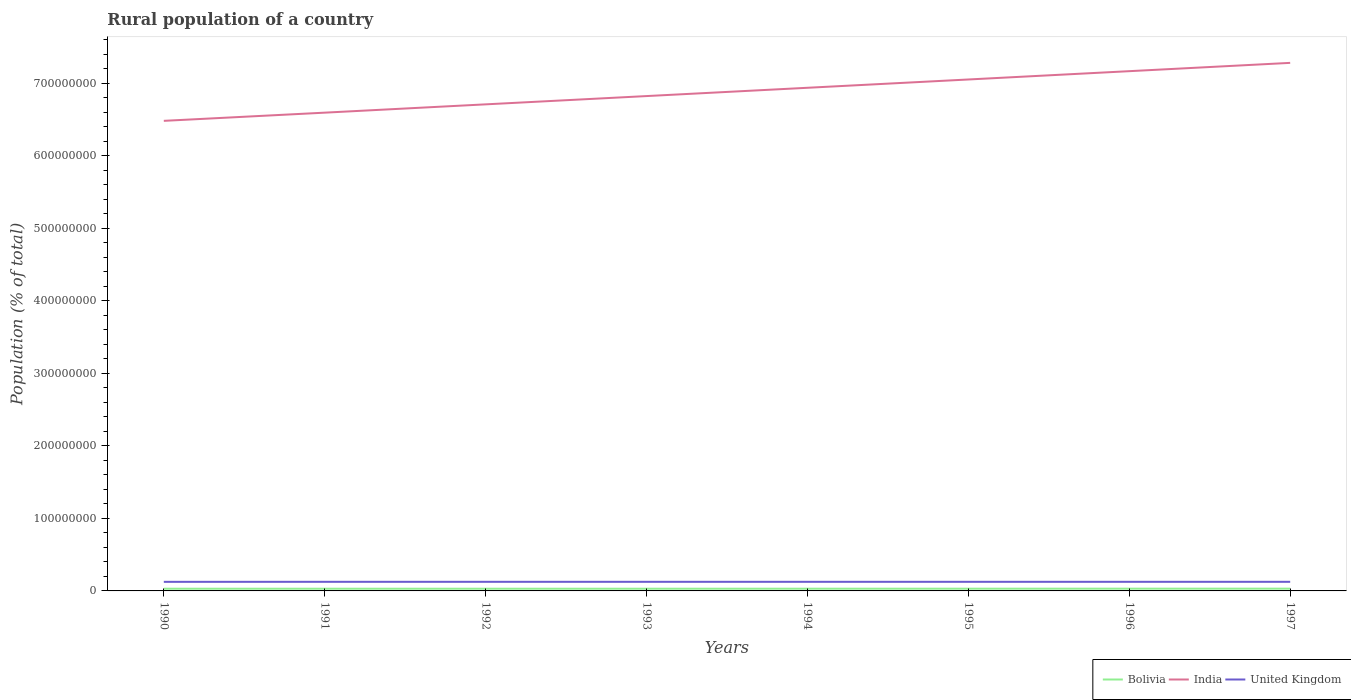Does the line corresponding to India intersect with the line corresponding to United Kingdom?
Keep it short and to the point. No. Across all years, what is the maximum rural population in Bolivia?
Your answer should be very brief. 3.03e+06. In which year was the rural population in Bolivia maximum?
Keep it short and to the point. 1992. What is the total rural population in Bolivia in the graph?
Offer a very short reply. -5.92e+04. What is the difference between the highest and the second highest rural population in Bolivia?
Ensure brevity in your answer.  9.09e+04. Is the rural population in Bolivia strictly greater than the rural population in India over the years?
Your answer should be very brief. Yes. How many years are there in the graph?
Keep it short and to the point. 8. What is the difference between two consecutive major ticks on the Y-axis?
Offer a very short reply. 1.00e+08. Are the values on the major ticks of Y-axis written in scientific E-notation?
Offer a terse response. No. What is the title of the graph?
Make the answer very short. Rural population of a country. What is the label or title of the Y-axis?
Ensure brevity in your answer.  Population (% of total). What is the Population (% of total) in Bolivia in 1990?
Provide a short and direct response. 3.05e+06. What is the Population (% of total) of India in 1990?
Your answer should be compact. 6.48e+08. What is the Population (% of total) in United Kingdom in 1990?
Your response must be concise. 1.25e+07. What is the Population (% of total) of Bolivia in 1991?
Ensure brevity in your answer.  3.04e+06. What is the Population (% of total) of India in 1991?
Give a very brief answer. 6.59e+08. What is the Population (% of total) of United Kingdom in 1991?
Provide a short and direct response. 1.26e+07. What is the Population (% of total) of Bolivia in 1992?
Provide a short and direct response. 3.03e+06. What is the Population (% of total) of India in 1992?
Your answer should be very brief. 6.71e+08. What is the Population (% of total) of United Kingdom in 1992?
Your answer should be compact. 1.26e+07. What is the Population (% of total) in Bolivia in 1993?
Offer a very short reply. 3.04e+06. What is the Population (% of total) in India in 1993?
Your answer should be very brief. 6.82e+08. What is the Population (% of total) of United Kingdom in 1993?
Ensure brevity in your answer.  1.26e+07. What is the Population (% of total) in Bolivia in 1994?
Give a very brief answer. 3.06e+06. What is the Population (% of total) of India in 1994?
Offer a very short reply. 6.94e+08. What is the Population (% of total) in United Kingdom in 1994?
Provide a short and direct response. 1.26e+07. What is the Population (% of total) of Bolivia in 1995?
Provide a succinct answer. 3.07e+06. What is the Population (% of total) in India in 1995?
Your answer should be very brief. 7.05e+08. What is the Population (% of total) of United Kingdom in 1995?
Give a very brief answer. 1.26e+07. What is the Population (% of total) in Bolivia in 1996?
Offer a terse response. 3.10e+06. What is the Population (% of total) in India in 1996?
Give a very brief answer. 7.17e+08. What is the Population (% of total) in United Kingdom in 1996?
Offer a terse response. 1.26e+07. What is the Population (% of total) in Bolivia in 1997?
Ensure brevity in your answer.  3.12e+06. What is the Population (% of total) in India in 1997?
Your answer should be compact. 7.28e+08. What is the Population (% of total) in United Kingdom in 1997?
Ensure brevity in your answer.  1.26e+07. Across all years, what is the maximum Population (% of total) in Bolivia?
Provide a succinct answer. 3.12e+06. Across all years, what is the maximum Population (% of total) of India?
Provide a succinct answer. 7.28e+08. Across all years, what is the maximum Population (% of total) of United Kingdom?
Your response must be concise. 1.26e+07. Across all years, what is the minimum Population (% of total) in Bolivia?
Ensure brevity in your answer.  3.03e+06. Across all years, what is the minimum Population (% of total) in India?
Provide a short and direct response. 6.48e+08. Across all years, what is the minimum Population (% of total) in United Kingdom?
Your answer should be very brief. 1.25e+07. What is the total Population (% of total) of Bolivia in the graph?
Keep it short and to the point. 2.45e+07. What is the total Population (% of total) of India in the graph?
Make the answer very short. 5.50e+09. What is the total Population (% of total) of United Kingdom in the graph?
Offer a terse response. 1.00e+08. What is the difference between the Population (% of total) of Bolivia in 1990 and that in 1991?
Provide a succinct answer. 9527. What is the difference between the Population (% of total) of India in 1990 and that in 1991?
Offer a very short reply. -1.13e+07. What is the difference between the Population (% of total) of United Kingdom in 1990 and that in 1991?
Provide a succinct answer. -5.48e+04. What is the difference between the Population (% of total) of Bolivia in 1990 and that in 1992?
Give a very brief answer. 1.82e+04. What is the difference between the Population (% of total) in India in 1990 and that in 1992?
Your answer should be very brief. -2.27e+07. What is the difference between the Population (% of total) of United Kingdom in 1990 and that in 1992?
Your answer should be compact. -5.43e+04. What is the difference between the Population (% of total) in Bolivia in 1990 and that in 1993?
Ensure brevity in your answer.  2891. What is the difference between the Population (% of total) in India in 1990 and that in 1993?
Make the answer very short. -3.42e+07. What is the difference between the Population (% of total) of United Kingdom in 1990 and that in 1993?
Your answer should be very brief. -4.99e+04. What is the difference between the Population (% of total) of Bolivia in 1990 and that in 1994?
Give a very brief answer. -1.19e+04. What is the difference between the Population (% of total) in India in 1990 and that in 1994?
Offer a very short reply. -4.56e+07. What is the difference between the Population (% of total) in United Kingdom in 1990 and that in 1994?
Make the answer very short. -4.66e+04. What is the difference between the Population (% of total) in Bolivia in 1990 and that in 1995?
Your answer should be compact. -2.63e+04. What is the difference between the Population (% of total) of India in 1990 and that in 1995?
Provide a short and direct response. -5.70e+07. What is the difference between the Population (% of total) in United Kingdom in 1990 and that in 1995?
Your response must be concise. -4.51e+04. What is the difference between the Population (% of total) of Bolivia in 1990 and that in 1996?
Your response must be concise. -4.96e+04. What is the difference between the Population (% of total) of India in 1990 and that in 1996?
Your response must be concise. -6.85e+07. What is the difference between the Population (% of total) of United Kingdom in 1990 and that in 1996?
Provide a succinct answer. -4.22e+04. What is the difference between the Population (% of total) of Bolivia in 1990 and that in 1997?
Offer a very short reply. -7.27e+04. What is the difference between the Population (% of total) of India in 1990 and that in 1997?
Your response must be concise. -7.99e+07. What is the difference between the Population (% of total) in United Kingdom in 1990 and that in 1997?
Provide a succinct answer. -4.02e+04. What is the difference between the Population (% of total) in Bolivia in 1991 and that in 1992?
Your response must be concise. 8674. What is the difference between the Population (% of total) in India in 1991 and that in 1992?
Keep it short and to the point. -1.15e+07. What is the difference between the Population (% of total) of United Kingdom in 1991 and that in 1992?
Provide a succinct answer. 511. What is the difference between the Population (% of total) of Bolivia in 1991 and that in 1993?
Your answer should be very brief. -6636. What is the difference between the Population (% of total) in India in 1991 and that in 1993?
Offer a very short reply. -2.29e+07. What is the difference between the Population (% of total) of United Kingdom in 1991 and that in 1993?
Give a very brief answer. 4973. What is the difference between the Population (% of total) of Bolivia in 1991 and that in 1994?
Offer a very short reply. -2.15e+04. What is the difference between the Population (% of total) of India in 1991 and that in 1994?
Your response must be concise. -3.43e+07. What is the difference between the Population (% of total) of United Kingdom in 1991 and that in 1994?
Give a very brief answer. 8244. What is the difference between the Population (% of total) of Bolivia in 1991 and that in 1995?
Keep it short and to the point. -3.59e+04. What is the difference between the Population (% of total) in India in 1991 and that in 1995?
Your response must be concise. -4.57e+07. What is the difference between the Population (% of total) in United Kingdom in 1991 and that in 1995?
Give a very brief answer. 9782. What is the difference between the Population (% of total) of Bolivia in 1991 and that in 1996?
Offer a terse response. -5.92e+04. What is the difference between the Population (% of total) of India in 1991 and that in 1996?
Provide a succinct answer. -5.72e+07. What is the difference between the Population (% of total) in United Kingdom in 1991 and that in 1996?
Your answer should be compact. 1.27e+04. What is the difference between the Population (% of total) of Bolivia in 1991 and that in 1997?
Offer a terse response. -8.22e+04. What is the difference between the Population (% of total) in India in 1991 and that in 1997?
Offer a very short reply. -6.87e+07. What is the difference between the Population (% of total) in United Kingdom in 1991 and that in 1997?
Offer a terse response. 1.47e+04. What is the difference between the Population (% of total) of Bolivia in 1992 and that in 1993?
Provide a short and direct response. -1.53e+04. What is the difference between the Population (% of total) in India in 1992 and that in 1993?
Your response must be concise. -1.14e+07. What is the difference between the Population (% of total) of United Kingdom in 1992 and that in 1993?
Provide a succinct answer. 4462. What is the difference between the Population (% of total) of Bolivia in 1992 and that in 1994?
Provide a succinct answer. -3.01e+04. What is the difference between the Population (% of total) in India in 1992 and that in 1994?
Keep it short and to the point. -2.28e+07. What is the difference between the Population (% of total) in United Kingdom in 1992 and that in 1994?
Offer a very short reply. 7733. What is the difference between the Population (% of total) of Bolivia in 1992 and that in 1995?
Your answer should be compact. -4.45e+04. What is the difference between the Population (% of total) in India in 1992 and that in 1995?
Your answer should be very brief. -3.43e+07. What is the difference between the Population (% of total) in United Kingdom in 1992 and that in 1995?
Ensure brevity in your answer.  9271. What is the difference between the Population (% of total) of Bolivia in 1992 and that in 1996?
Your answer should be very brief. -6.78e+04. What is the difference between the Population (% of total) in India in 1992 and that in 1996?
Provide a short and direct response. -4.57e+07. What is the difference between the Population (% of total) in United Kingdom in 1992 and that in 1996?
Offer a terse response. 1.22e+04. What is the difference between the Population (% of total) in Bolivia in 1992 and that in 1997?
Provide a short and direct response. -9.09e+04. What is the difference between the Population (% of total) of India in 1992 and that in 1997?
Make the answer very short. -5.72e+07. What is the difference between the Population (% of total) in United Kingdom in 1992 and that in 1997?
Ensure brevity in your answer.  1.42e+04. What is the difference between the Population (% of total) of Bolivia in 1993 and that in 1994?
Your answer should be compact. -1.48e+04. What is the difference between the Population (% of total) in India in 1993 and that in 1994?
Your answer should be very brief. -1.14e+07. What is the difference between the Population (% of total) in United Kingdom in 1993 and that in 1994?
Provide a succinct answer. 3271. What is the difference between the Population (% of total) in Bolivia in 1993 and that in 1995?
Offer a very short reply. -2.92e+04. What is the difference between the Population (% of total) of India in 1993 and that in 1995?
Your response must be concise. -2.29e+07. What is the difference between the Population (% of total) of United Kingdom in 1993 and that in 1995?
Give a very brief answer. 4809. What is the difference between the Population (% of total) of Bolivia in 1993 and that in 1996?
Your answer should be very brief. -5.25e+04. What is the difference between the Population (% of total) in India in 1993 and that in 1996?
Make the answer very short. -3.43e+07. What is the difference between the Population (% of total) of United Kingdom in 1993 and that in 1996?
Give a very brief answer. 7689. What is the difference between the Population (% of total) of Bolivia in 1993 and that in 1997?
Provide a succinct answer. -7.56e+04. What is the difference between the Population (% of total) of India in 1993 and that in 1997?
Make the answer very short. -4.58e+07. What is the difference between the Population (% of total) of United Kingdom in 1993 and that in 1997?
Your answer should be very brief. 9714. What is the difference between the Population (% of total) in Bolivia in 1994 and that in 1995?
Make the answer very short. -1.44e+04. What is the difference between the Population (% of total) of India in 1994 and that in 1995?
Your answer should be very brief. -1.14e+07. What is the difference between the Population (% of total) of United Kingdom in 1994 and that in 1995?
Make the answer very short. 1538. What is the difference between the Population (% of total) of Bolivia in 1994 and that in 1996?
Your answer should be compact. -3.77e+04. What is the difference between the Population (% of total) of India in 1994 and that in 1996?
Ensure brevity in your answer.  -2.29e+07. What is the difference between the Population (% of total) in United Kingdom in 1994 and that in 1996?
Ensure brevity in your answer.  4418. What is the difference between the Population (% of total) in Bolivia in 1994 and that in 1997?
Give a very brief answer. -6.08e+04. What is the difference between the Population (% of total) in India in 1994 and that in 1997?
Your answer should be compact. -3.44e+07. What is the difference between the Population (% of total) of United Kingdom in 1994 and that in 1997?
Your answer should be compact. 6443. What is the difference between the Population (% of total) in Bolivia in 1995 and that in 1996?
Your answer should be very brief. -2.33e+04. What is the difference between the Population (% of total) in India in 1995 and that in 1996?
Provide a succinct answer. -1.15e+07. What is the difference between the Population (% of total) in United Kingdom in 1995 and that in 1996?
Keep it short and to the point. 2880. What is the difference between the Population (% of total) in Bolivia in 1995 and that in 1997?
Your answer should be very brief. -4.63e+04. What is the difference between the Population (% of total) in India in 1995 and that in 1997?
Ensure brevity in your answer.  -2.29e+07. What is the difference between the Population (% of total) of United Kingdom in 1995 and that in 1997?
Your answer should be very brief. 4905. What is the difference between the Population (% of total) in Bolivia in 1996 and that in 1997?
Your answer should be compact. -2.30e+04. What is the difference between the Population (% of total) in India in 1996 and that in 1997?
Provide a short and direct response. -1.15e+07. What is the difference between the Population (% of total) in United Kingdom in 1996 and that in 1997?
Offer a very short reply. 2025. What is the difference between the Population (% of total) in Bolivia in 1990 and the Population (% of total) in India in 1991?
Your response must be concise. -6.56e+08. What is the difference between the Population (% of total) of Bolivia in 1990 and the Population (% of total) of United Kingdom in 1991?
Provide a succinct answer. -9.52e+06. What is the difference between the Population (% of total) in India in 1990 and the Population (% of total) in United Kingdom in 1991?
Offer a very short reply. 6.36e+08. What is the difference between the Population (% of total) of Bolivia in 1990 and the Population (% of total) of India in 1992?
Your response must be concise. -6.68e+08. What is the difference between the Population (% of total) of Bolivia in 1990 and the Population (% of total) of United Kingdom in 1992?
Your answer should be compact. -9.52e+06. What is the difference between the Population (% of total) of India in 1990 and the Population (% of total) of United Kingdom in 1992?
Offer a terse response. 6.36e+08. What is the difference between the Population (% of total) in Bolivia in 1990 and the Population (% of total) in India in 1993?
Keep it short and to the point. -6.79e+08. What is the difference between the Population (% of total) in Bolivia in 1990 and the Population (% of total) in United Kingdom in 1993?
Your answer should be compact. -9.52e+06. What is the difference between the Population (% of total) of India in 1990 and the Population (% of total) of United Kingdom in 1993?
Keep it short and to the point. 6.36e+08. What is the difference between the Population (% of total) in Bolivia in 1990 and the Population (% of total) in India in 1994?
Offer a terse response. -6.91e+08. What is the difference between the Population (% of total) in Bolivia in 1990 and the Population (% of total) in United Kingdom in 1994?
Your answer should be very brief. -9.52e+06. What is the difference between the Population (% of total) of India in 1990 and the Population (% of total) of United Kingdom in 1994?
Provide a short and direct response. 6.36e+08. What is the difference between the Population (% of total) in Bolivia in 1990 and the Population (% of total) in India in 1995?
Your answer should be very brief. -7.02e+08. What is the difference between the Population (% of total) of Bolivia in 1990 and the Population (% of total) of United Kingdom in 1995?
Make the answer very short. -9.51e+06. What is the difference between the Population (% of total) of India in 1990 and the Population (% of total) of United Kingdom in 1995?
Make the answer very short. 6.36e+08. What is the difference between the Population (% of total) in Bolivia in 1990 and the Population (% of total) in India in 1996?
Offer a very short reply. -7.14e+08. What is the difference between the Population (% of total) in Bolivia in 1990 and the Population (% of total) in United Kingdom in 1996?
Provide a short and direct response. -9.51e+06. What is the difference between the Population (% of total) of India in 1990 and the Population (% of total) of United Kingdom in 1996?
Give a very brief answer. 6.36e+08. What is the difference between the Population (% of total) in Bolivia in 1990 and the Population (% of total) in India in 1997?
Give a very brief answer. -7.25e+08. What is the difference between the Population (% of total) in Bolivia in 1990 and the Population (% of total) in United Kingdom in 1997?
Provide a short and direct response. -9.51e+06. What is the difference between the Population (% of total) in India in 1990 and the Population (% of total) in United Kingdom in 1997?
Keep it short and to the point. 6.36e+08. What is the difference between the Population (% of total) of Bolivia in 1991 and the Population (% of total) of India in 1992?
Your answer should be compact. -6.68e+08. What is the difference between the Population (% of total) in Bolivia in 1991 and the Population (% of total) in United Kingdom in 1992?
Your response must be concise. -9.53e+06. What is the difference between the Population (% of total) of India in 1991 and the Population (% of total) of United Kingdom in 1992?
Make the answer very short. 6.47e+08. What is the difference between the Population (% of total) of Bolivia in 1991 and the Population (% of total) of India in 1993?
Your response must be concise. -6.79e+08. What is the difference between the Population (% of total) in Bolivia in 1991 and the Population (% of total) in United Kingdom in 1993?
Offer a very short reply. -9.53e+06. What is the difference between the Population (% of total) in India in 1991 and the Population (% of total) in United Kingdom in 1993?
Keep it short and to the point. 6.47e+08. What is the difference between the Population (% of total) of Bolivia in 1991 and the Population (% of total) of India in 1994?
Offer a very short reply. -6.91e+08. What is the difference between the Population (% of total) of Bolivia in 1991 and the Population (% of total) of United Kingdom in 1994?
Your answer should be compact. -9.52e+06. What is the difference between the Population (% of total) in India in 1991 and the Population (% of total) in United Kingdom in 1994?
Make the answer very short. 6.47e+08. What is the difference between the Population (% of total) in Bolivia in 1991 and the Population (% of total) in India in 1995?
Your answer should be compact. -7.02e+08. What is the difference between the Population (% of total) in Bolivia in 1991 and the Population (% of total) in United Kingdom in 1995?
Ensure brevity in your answer.  -9.52e+06. What is the difference between the Population (% of total) in India in 1991 and the Population (% of total) in United Kingdom in 1995?
Ensure brevity in your answer.  6.47e+08. What is the difference between the Population (% of total) in Bolivia in 1991 and the Population (% of total) in India in 1996?
Ensure brevity in your answer.  -7.14e+08. What is the difference between the Population (% of total) of Bolivia in 1991 and the Population (% of total) of United Kingdom in 1996?
Make the answer very short. -9.52e+06. What is the difference between the Population (% of total) in India in 1991 and the Population (% of total) in United Kingdom in 1996?
Give a very brief answer. 6.47e+08. What is the difference between the Population (% of total) in Bolivia in 1991 and the Population (% of total) in India in 1997?
Your response must be concise. -7.25e+08. What is the difference between the Population (% of total) in Bolivia in 1991 and the Population (% of total) in United Kingdom in 1997?
Your answer should be compact. -9.52e+06. What is the difference between the Population (% of total) of India in 1991 and the Population (% of total) of United Kingdom in 1997?
Make the answer very short. 6.47e+08. What is the difference between the Population (% of total) in Bolivia in 1992 and the Population (% of total) in India in 1993?
Provide a short and direct response. -6.79e+08. What is the difference between the Population (% of total) in Bolivia in 1992 and the Population (% of total) in United Kingdom in 1993?
Offer a terse response. -9.54e+06. What is the difference between the Population (% of total) in India in 1992 and the Population (% of total) in United Kingdom in 1993?
Offer a terse response. 6.58e+08. What is the difference between the Population (% of total) in Bolivia in 1992 and the Population (% of total) in India in 1994?
Offer a terse response. -6.91e+08. What is the difference between the Population (% of total) in Bolivia in 1992 and the Population (% of total) in United Kingdom in 1994?
Your response must be concise. -9.53e+06. What is the difference between the Population (% of total) of India in 1992 and the Population (% of total) of United Kingdom in 1994?
Provide a succinct answer. 6.58e+08. What is the difference between the Population (% of total) in Bolivia in 1992 and the Population (% of total) in India in 1995?
Offer a terse response. -7.02e+08. What is the difference between the Population (% of total) of Bolivia in 1992 and the Population (% of total) of United Kingdom in 1995?
Make the answer very short. -9.53e+06. What is the difference between the Population (% of total) in India in 1992 and the Population (% of total) in United Kingdom in 1995?
Keep it short and to the point. 6.58e+08. What is the difference between the Population (% of total) of Bolivia in 1992 and the Population (% of total) of India in 1996?
Give a very brief answer. -7.14e+08. What is the difference between the Population (% of total) in Bolivia in 1992 and the Population (% of total) in United Kingdom in 1996?
Offer a terse response. -9.53e+06. What is the difference between the Population (% of total) in India in 1992 and the Population (% of total) in United Kingdom in 1996?
Offer a very short reply. 6.58e+08. What is the difference between the Population (% of total) of Bolivia in 1992 and the Population (% of total) of India in 1997?
Your answer should be very brief. -7.25e+08. What is the difference between the Population (% of total) of Bolivia in 1992 and the Population (% of total) of United Kingdom in 1997?
Offer a very short reply. -9.53e+06. What is the difference between the Population (% of total) in India in 1992 and the Population (% of total) in United Kingdom in 1997?
Provide a short and direct response. 6.58e+08. What is the difference between the Population (% of total) of Bolivia in 1993 and the Population (% of total) of India in 1994?
Make the answer very short. -6.91e+08. What is the difference between the Population (% of total) in Bolivia in 1993 and the Population (% of total) in United Kingdom in 1994?
Your response must be concise. -9.52e+06. What is the difference between the Population (% of total) in India in 1993 and the Population (% of total) in United Kingdom in 1994?
Provide a short and direct response. 6.70e+08. What is the difference between the Population (% of total) of Bolivia in 1993 and the Population (% of total) of India in 1995?
Provide a short and direct response. -7.02e+08. What is the difference between the Population (% of total) in Bolivia in 1993 and the Population (% of total) in United Kingdom in 1995?
Offer a terse response. -9.52e+06. What is the difference between the Population (% of total) in India in 1993 and the Population (% of total) in United Kingdom in 1995?
Offer a very short reply. 6.70e+08. What is the difference between the Population (% of total) of Bolivia in 1993 and the Population (% of total) of India in 1996?
Provide a succinct answer. -7.14e+08. What is the difference between the Population (% of total) in Bolivia in 1993 and the Population (% of total) in United Kingdom in 1996?
Your response must be concise. -9.51e+06. What is the difference between the Population (% of total) of India in 1993 and the Population (% of total) of United Kingdom in 1996?
Your answer should be very brief. 6.70e+08. What is the difference between the Population (% of total) in Bolivia in 1993 and the Population (% of total) in India in 1997?
Offer a terse response. -7.25e+08. What is the difference between the Population (% of total) of Bolivia in 1993 and the Population (% of total) of United Kingdom in 1997?
Offer a terse response. -9.51e+06. What is the difference between the Population (% of total) of India in 1993 and the Population (% of total) of United Kingdom in 1997?
Provide a short and direct response. 6.70e+08. What is the difference between the Population (% of total) in Bolivia in 1994 and the Population (% of total) in India in 1995?
Keep it short and to the point. -7.02e+08. What is the difference between the Population (% of total) of Bolivia in 1994 and the Population (% of total) of United Kingdom in 1995?
Your answer should be very brief. -9.50e+06. What is the difference between the Population (% of total) of India in 1994 and the Population (% of total) of United Kingdom in 1995?
Your answer should be compact. 6.81e+08. What is the difference between the Population (% of total) of Bolivia in 1994 and the Population (% of total) of India in 1996?
Ensure brevity in your answer.  -7.14e+08. What is the difference between the Population (% of total) in Bolivia in 1994 and the Population (% of total) in United Kingdom in 1996?
Offer a very short reply. -9.50e+06. What is the difference between the Population (% of total) in India in 1994 and the Population (% of total) in United Kingdom in 1996?
Make the answer very short. 6.81e+08. What is the difference between the Population (% of total) in Bolivia in 1994 and the Population (% of total) in India in 1997?
Ensure brevity in your answer.  -7.25e+08. What is the difference between the Population (% of total) in Bolivia in 1994 and the Population (% of total) in United Kingdom in 1997?
Make the answer very short. -9.50e+06. What is the difference between the Population (% of total) in India in 1994 and the Population (% of total) in United Kingdom in 1997?
Make the answer very short. 6.81e+08. What is the difference between the Population (% of total) in Bolivia in 1995 and the Population (% of total) in India in 1996?
Make the answer very short. -7.14e+08. What is the difference between the Population (% of total) of Bolivia in 1995 and the Population (% of total) of United Kingdom in 1996?
Provide a succinct answer. -9.48e+06. What is the difference between the Population (% of total) of India in 1995 and the Population (% of total) of United Kingdom in 1996?
Give a very brief answer. 6.93e+08. What is the difference between the Population (% of total) in Bolivia in 1995 and the Population (% of total) in India in 1997?
Your answer should be very brief. -7.25e+08. What is the difference between the Population (% of total) of Bolivia in 1995 and the Population (% of total) of United Kingdom in 1997?
Provide a succinct answer. -9.48e+06. What is the difference between the Population (% of total) in India in 1995 and the Population (% of total) in United Kingdom in 1997?
Your response must be concise. 6.93e+08. What is the difference between the Population (% of total) in Bolivia in 1996 and the Population (% of total) in India in 1997?
Your answer should be compact. -7.25e+08. What is the difference between the Population (% of total) in Bolivia in 1996 and the Population (% of total) in United Kingdom in 1997?
Your answer should be very brief. -9.46e+06. What is the difference between the Population (% of total) of India in 1996 and the Population (% of total) of United Kingdom in 1997?
Your answer should be compact. 7.04e+08. What is the average Population (% of total) in Bolivia per year?
Your answer should be compact. 3.06e+06. What is the average Population (% of total) of India per year?
Provide a succinct answer. 6.88e+08. What is the average Population (% of total) in United Kingdom per year?
Ensure brevity in your answer.  1.26e+07. In the year 1990, what is the difference between the Population (% of total) of Bolivia and Population (% of total) of India?
Your answer should be compact. -6.45e+08. In the year 1990, what is the difference between the Population (% of total) of Bolivia and Population (% of total) of United Kingdom?
Ensure brevity in your answer.  -9.47e+06. In the year 1990, what is the difference between the Population (% of total) in India and Population (% of total) in United Kingdom?
Your response must be concise. 6.36e+08. In the year 1991, what is the difference between the Population (% of total) in Bolivia and Population (% of total) in India?
Ensure brevity in your answer.  -6.56e+08. In the year 1991, what is the difference between the Population (% of total) of Bolivia and Population (% of total) of United Kingdom?
Your answer should be compact. -9.53e+06. In the year 1991, what is the difference between the Population (% of total) in India and Population (% of total) in United Kingdom?
Make the answer very short. 6.47e+08. In the year 1992, what is the difference between the Population (% of total) in Bolivia and Population (% of total) in India?
Give a very brief answer. -6.68e+08. In the year 1992, what is the difference between the Population (% of total) of Bolivia and Population (% of total) of United Kingdom?
Provide a short and direct response. -9.54e+06. In the year 1992, what is the difference between the Population (% of total) in India and Population (% of total) in United Kingdom?
Give a very brief answer. 6.58e+08. In the year 1993, what is the difference between the Population (% of total) in Bolivia and Population (% of total) in India?
Ensure brevity in your answer.  -6.79e+08. In the year 1993, what is the difference between the Population (% of total) of Bolivia and Population (% of total) of United Kingdom?
Provide a short and direct response. -9.52e+06. In the year 1993, what is the difference between the Population (% of total) of India and Population (% of total) of United Kingdom?
Your answer should be very brief. 6.70e+08. In the year 1994, what is the difference between the Population (% of total) of Bolivia and Population (% of total) of India?
Keep it short and to the point. -6.91e+08. In the year 1994, what is the difference between the Population (% of total) in Bolivia and Population (% of total) in United Kingdom?
Your answer should be compact. -9.50e+06. In the year 1994, what is the difference between the Population (% of total) of India and Population (% of total) of United Kingdom?
Offer a terse response. 6.81e+08. In the year 1995, what is the difference between the Population (% of total) in Bolivia and Population (% of total) in India?
Offer a very short reply. -7.02e+08. In the year 1995, what is the difference between the Population (% of total) in Bolivia and Population (% of total) in United Kingdom?
Provide a short and direct response. -9.49e+06. In the year 1995, what is the difference between the Population (% of total) in India and Population (% of total) in United Kingdom?
Give a very brief answer. 6.93e+08. In the year 1996, what is the difference between the Population (% of total) in Bolivia and Population (% of total) in India?
Offer a terse response. -7.14e+08. In the year 1996, what is the difference between the Population (% of total) in Bolivia and Population (% of total) in United Kingdom?
Your answer should be compact. -9.46e+06. In the year 1996, what is the difference between the Population (% of total) in India and Population (% of total) in United Kingdom?
Ensure brevity in your answer.  7.04e+08. In the year 1997, what is the difference between the Population (% of total) in Bolivia and Population (% of total) in India?
Ensure brevity in your answer.  -7.25e+08. In the year 1997, what is the difference between the Population (% of total) of Bolivia and Population (% of total) of United Kingdom?
Provide a short and direct response. -9.44e+06. In the year 1997, what is the difference between the Population (% of total) of India and Population (% of total) of United Kingdom?
Give a very brief answer. 7.16e+08. What is the ratio of the Population (% of total) of India in 1990 to that in 1991?
Provide a short and direct response. 0.98. What is the ratio of the Population (% of total) in India in 1990 to that in 1992?
Keep it short and to the point. 0.97. What is the ratio of the Population (% of total) in Bolivia in 1990 to that in 1993?
Keep it short and to the point. 1. What is the ratio of the Population (% of total) in India in 1990 to that in 1993?
Make the answer very short. 0.95. What is the ratio of the Population (% of total) in United Kingdom in 1990 to that in 1993?
Provide a short and direct response. 1. What is the ratio of the Population (% of total) in India in 1990 to that in 1994?
Offer a very short reply. 0.93. What is the ratio of the Population (% of total) in India in 1990 to that in 1995?
Provide a succinct answer. 0.92. What is the ratio of the Population (% of total) in Bolivia in 1990 to that in 1996?
Ensure brevity in your answer.  0.98. What is the ratio of the Population (% of total) of India in 1990 to that in 1996?
Offer a very short reply. 0.9. What is the ratio of the Population (% of total) of Bolivia in 1990 to that in 1997?
Your response must be concise. 0.98. What is the ratio of the Population (% of total) of India in 1990 to that in 1997?
Keep it short and to the point. 0.89. What is the ratio of the Population (% of total) in United Kingdom in 1990 to that in 1997?
Your answer should be compact. 1. What is the ratio of the Population (% of total) in Bolivia in 1991 to that in 1992?
Provide a short and direct response. 1. What is the ratio of the Population (% of total) of India in 1991 to that in 1992?
Provide a succinct answer. 0.98. What is the ratio of the Population (% of total) of Bolivia in 1991 to that in 1993?
Make the answer very short. 1. What is the ratio of the Population (% of total) of India in 1991 to that in 1993?
Give a very brief answer. 0.97. What is the ratio of the Population (% of total) of United Kingdom in 1991 to that in 1993?
Offer a very short reply. 1. What is the ratio of the Population (% of total) in Bolivia in 1991 to that in 1994?
Provide a short and direct response. 0.99. What is the ratio of the Population (% of total) in India in 1991 to that in 1994?
Provide a succinct answer. 0.95. What is the ratio of the Population (% of total) in Bolivia in 1991 to that in 1995?
Provide a short and direct response. 0.99. What is the ratio of the Population (% of total) of India in 1991 to that in 1995?
Offer a terse response. 0.94. What is the ratio of the Population (% of total) of Bolivia in 1991 to that in 1996?
Your response must be concise. 0.98. What is the ratio of the Population (% of total) in India in 1991 to that in 1996?
Provide a short and direct response. 0.92. What is the ratio of the Population (% of total) in Bolivia in 1991 to that in 1997?
Give a very brief answer. 0.97. What is the ratio of the Population (% of total) in India in 1991 to that in 1997?
Your answer should be compact. 0.91. What is the ratio of the Population (% of total) of United Kingdom in 1991 to that in 1997?
Ensure brevity in your answer.  1. What is the ratio of the Population (% of total) of India in 1992 to that in 1993?
Make the answer very short. 0.98. What is the ratio of the Population (% of total) of United Kingdom in 1992 to that in 1993?
Provide a short and direct response. 1. What is the ratio of the Population (% of total) of India in 1992 to that in 1994?
Provide a succinct answer. 0.97. What is the ratio of the Population (% of total) of Bolivia in 1992 to that in 1995?
Provide a succinct answer. 0.99. What is the ratio of the Population (% of total) of India in 1992 to that in 1995?
Your response must be concise. 0.95. What is the ratio of the Population (% of total) in United Kingdom in 1992 to that in 1995?
Ensure brevity in your answer.  1. What is the ratio of the Population (% of total) of Bolivia in 1992 to that in 1996?
Give a very brief answer. 0.98. What is the ratio of the Population (% of total) in India in 1992 to that in 1996?
Provide a succinct answer. 0.94. What is the ratio of the Population (% of total) in Bolivia in 1992 to that in 1997?
Your answer should be compact. 0.97. What is the ratio of the Population (% of total) in India in 1992 to that in 1997?
Offer a very short reply. 0.92. What is the ratio of the Population (% of total) of United Kingdom in 1992 to that in 1997?
Keep it short and to the point. 1. What is the ratio of the Population (% of total) of India in 1993 to that in 1994?
Your response must be concise. 0.98. What is the ratio of the Population (% of total) of United Kingdom in 1993 to that in 1994?
Keep it short and to the point. 1. What is the ratio of the Population (% of total) of India in 1993 to that in 1995?
Your answer should be compact. 0.97. What is the ratio of the Population (% of total) of United Kingdom in 1993 to that in 1995?
Ensure brevity in your answer.  1. What is the ratio of the Population (% of total) of India in 1993 to that in 1996?
Make the answer very short. 0.95. What is the ratio of the Population (% of total) in United Kingdom in 1993 to that in 1996?
Your answer should be very brief. 1. What is the ratio of the Population (% of total) in Bolivia in 1993 to that in 1997?
Offer a very short reply. 0.98. What is the ratio of the Population (% of total) of India in 1993 to that in 1997?
Provide a short and direct response. 0.94. What is the ratio of the Population (% of total) in India in 1994 to that in 1995?
Make the answer very short. 0.98. What is the ratio of the Population (% of total) of United Kingdom in 1994 to that in 1995?
Ensure brevity in your answer.  1. What is the ratio of the Population (% of total) in United Kingdom in 1994 to that in 1996?
Offer a terse response. 1. What is the ratio of the Population (% of total) of Bolivia in 1994 to that in 1997?
Your answer should be compact. 0.98. What is the ratio of the Population (% of total) in India in 1994 to that in 1997?
Provide a succinct answer. 0.95. What is the ratio of the Population (% of total) in United Kingdom in 1994 to that in 1997?
Provide a short and direct response. 1. What is the ratio of the Population (% of total) in Bolivia in 1995 to that in 1997?
Your response must be concise. 0.99. What is the ratio of the Population (% of total) in India in 1995 to that in 1997?
Provide a short and direct response. 0.97. What is the ratio of the Population (% of total) of India in 1996 to that in 1997?
Your answer should be compact. 0.98. What is the difference between the highest and the second highest Population (% of total) in Bolivia?
Offer a terse response. 2.30e+04. What is the difference between the highest and the second highest Population (% of total) in India?
Ensure brevity in your answer.  1.15e+07. What is the difference between the highest and the second highest Population (% of total) in United Kingdom?
Your response must be concise. 511. What is the difference between the highest and the lowest Population (% of total) in Bolivia?
Offer a terse response. 9.09e+04. What is the difference between the highest and the lowest Population (% of total) of India?
Provide a succinct answer. 7.99e+07. What is the difference between the highest and the lowest Population (% of total) of United Kingdom?
Ensure brevity in your answer.  5.48e+04. 